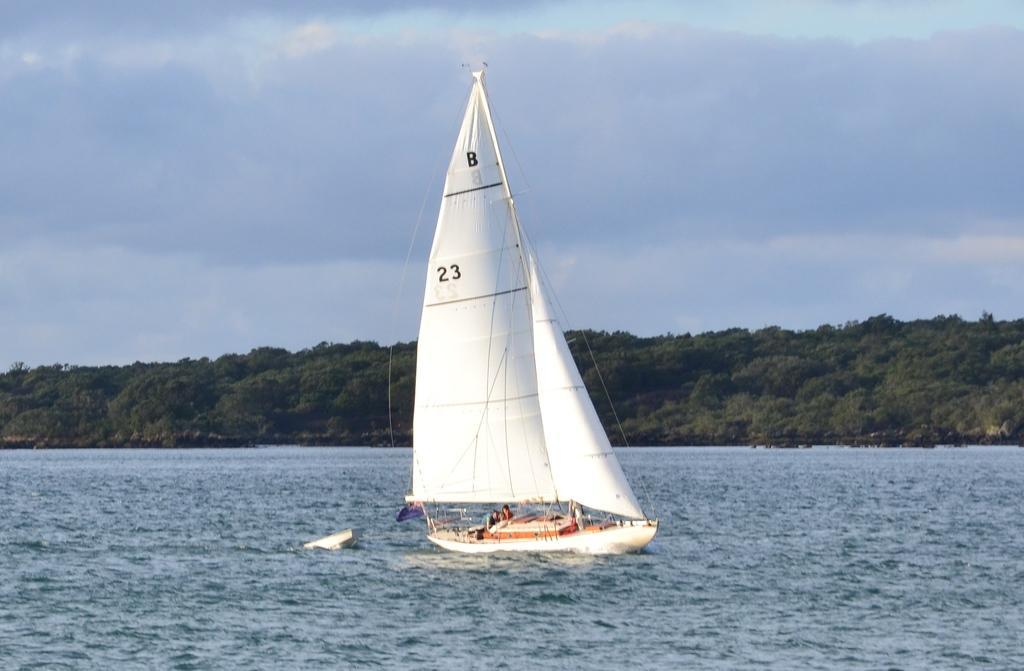Describe this image in one or two sentences. In this picture there is a white color ship on the water and there are trees in the background and the sky is cloudy. 